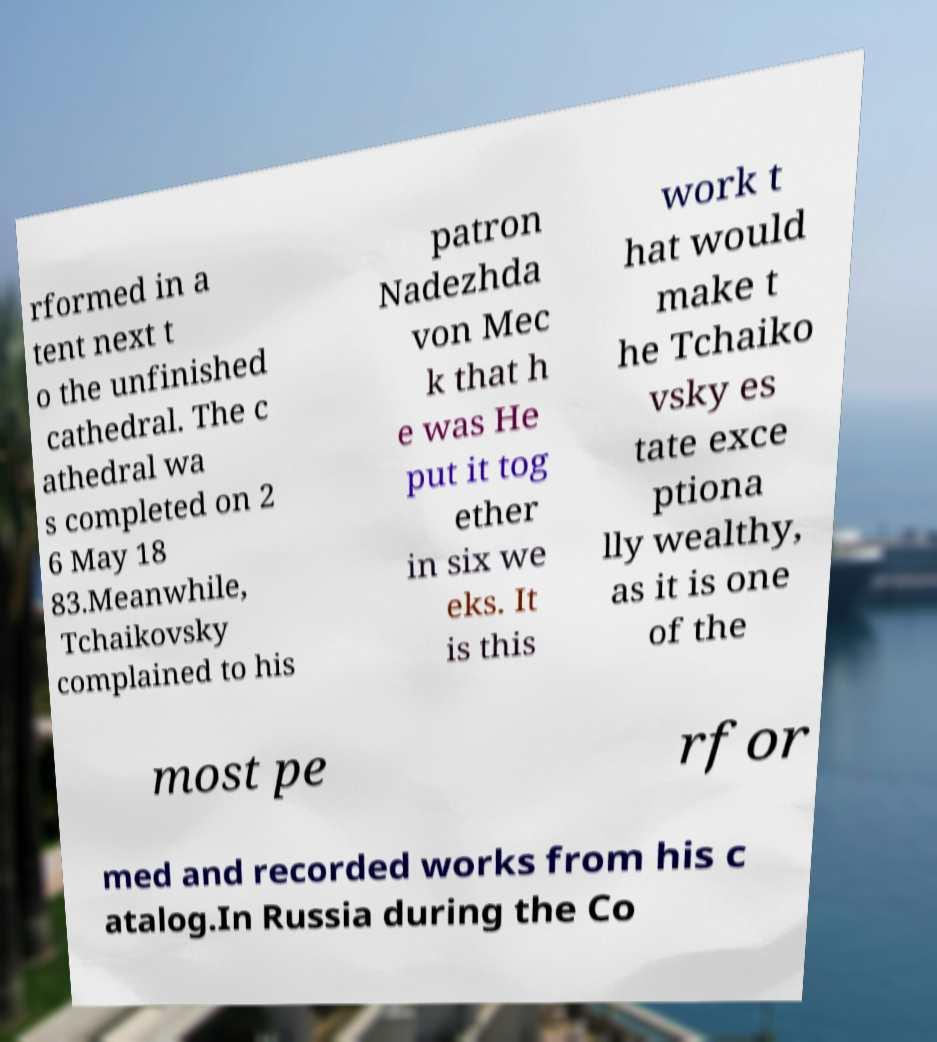Please read and relay the text visible in this image. What does it say? rformed in a tent next t o the unfinished cathedral. The c athedral wa s completed on 2 6 May 18 83.Meanwhile, Tchaikovsky complained to his patron Nadezhda von Mec k that h e was He put it tog ether in six we eks. It is this work t hat would make t he Tchaiko vsky es tate exce ptiona lly wealthy, as it is one of the most pe rfor med and recorded works from his c atalog.In Russia during the Co 